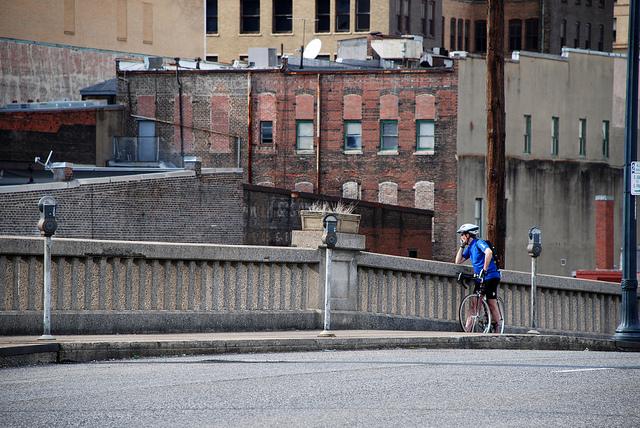What is the man leaning on?
Answer briefly. Railing. Are there any cars on the road?
Give a very brief answer. No. Is the man riding the bike?
Short answer required. Yes. How many people are in the photo?
Quick response, please. 1. 